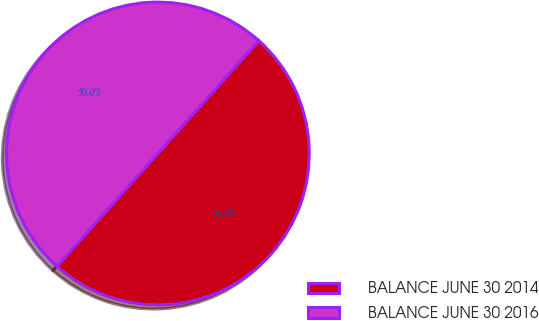Convert chart to OTSL. <chart><loc_0><loc_0><loc_500><loc_500><pie_chart><fcel>BALANCE JUNE 30 2014<fcel>BALANCE JUNE 30 2016<nl><fcel>50.0%<fcel>50.0%<nl></chart> 